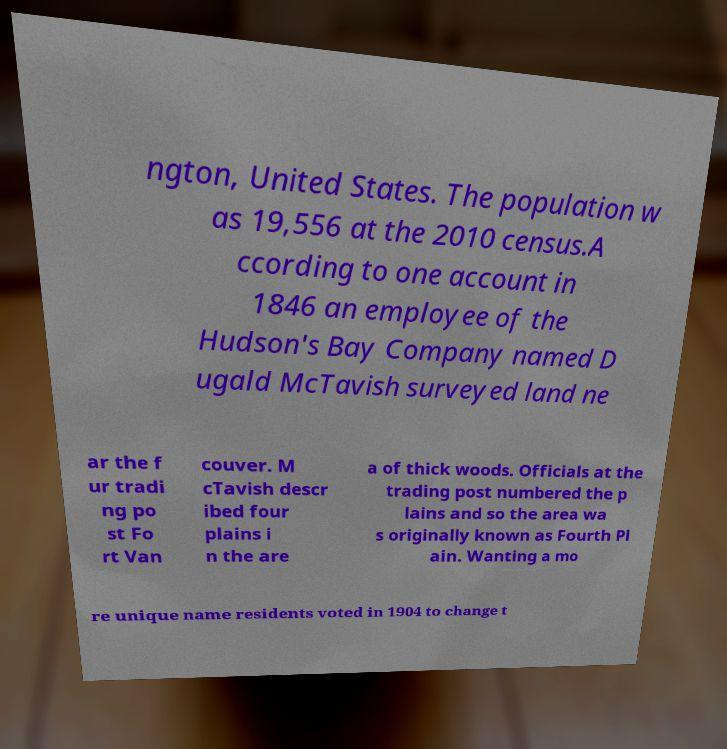Please identify and transcribe the text found in this image. ngton, United States. The population w as 19,556 at the 2010 census.A ccording to one account in 1846 an employee of the Hudson's Bay Company named D ugald McTavish surveyed land ne ar the f ur tradi ng po st Fo rt Van couver. M cTavish descr ibed four plains i n the are a of thick woods. Officials at the trading post numbered the p lains and so the area wa s originally known as Fourth Pl ain. Wanting a mo re unique name residents voted in 1904 to change t 